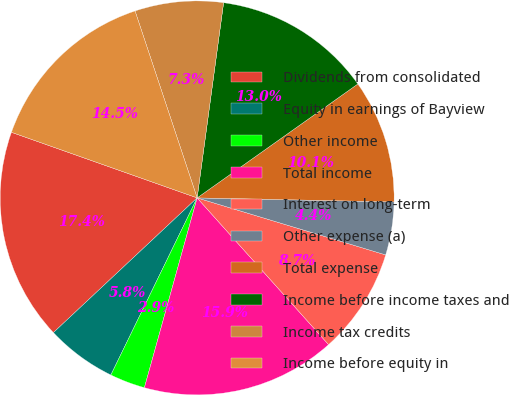Convert chart. <chart><loc_0><loc_0><loc_500><loc_500><pie_chart><fcel>Dividends from consolidated<fcel>Equity in earnings of Bayview<fcel>Other income<fcel>Total income<fcel>Interest on long-term<fcel>Other expense (a)<fcel>Total expense<fcel>Income before income taxes and<fcel>Income tax credits<fcel>Income before equity in<nl><fcel>17.39%<fcel>5.8%<fcel>2.9%<fcel>15.94%<fcel>8.7%<fcel>4.35%<fcel>10.14%<fcel>13.04%<fcel>7.25%<fcel>14.49%<nl></chart> 